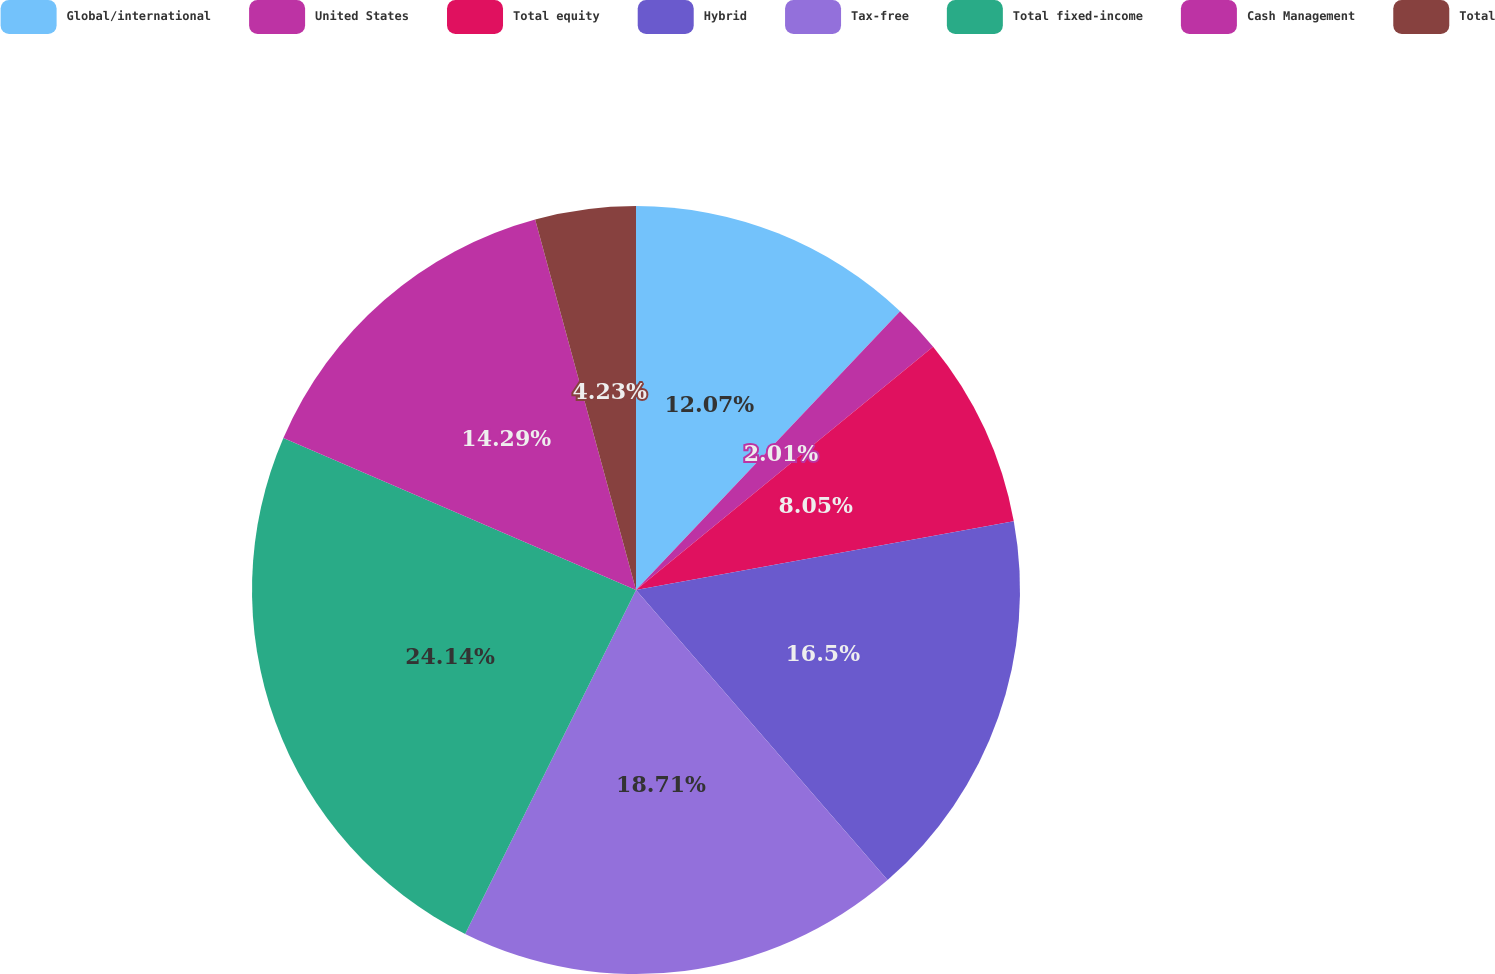Convert chart to OTSL. <chart><loc_0><loc_0><loc_500><loc_500><pie_chart><fcel>Global/international<fcel>United States<fcel>Total equity<fcel>Hybrid<fcel>Tax-free<fcel>Total fixed-income<fcel>Cash Management<fcel>Total<nl><fcel>12.07%<fcel>2.01%<fcel>8.05%<fcel>16.5%<fcel>18.71%<fcel>24.14%<fcel>14.29%<fcel>4.23%<nl></chart> 